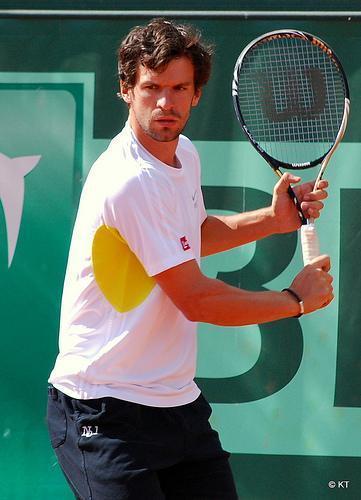How many people are in the picture?
Give a very brief answer. 1. 